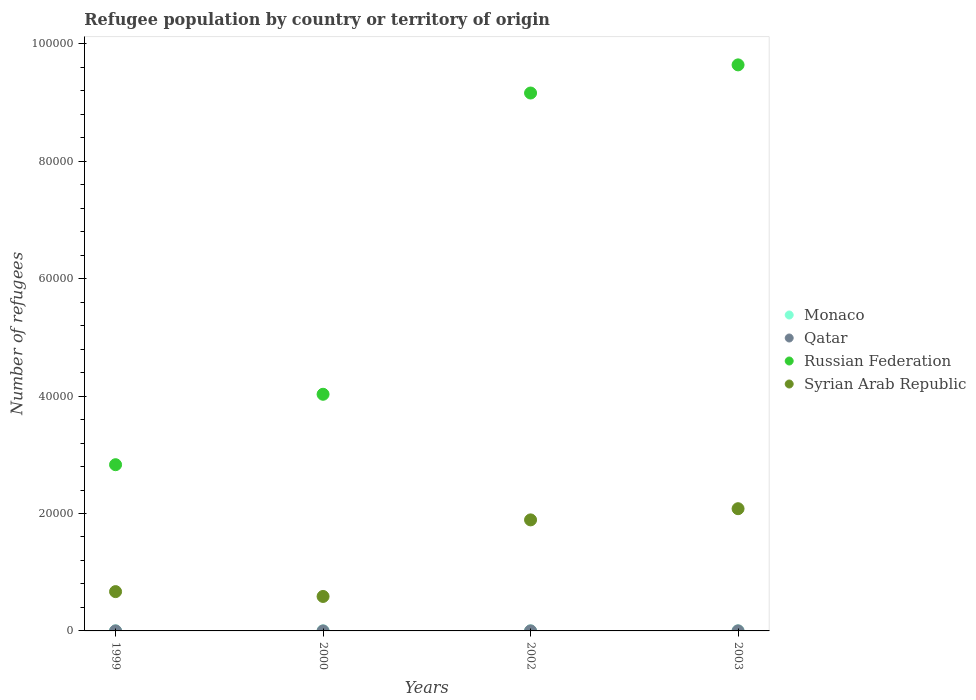What is the number of refugees in Qatar in 2003?
Your answer should be compact. 13. Across all years, what is the maximum number of refugees in Qatar?
Make the answer very short. 13. Across all years, what is the minimum number of refugees in Monaco?
Provide a succinct answer. 1. In which year was the number of refugees in Monaco maximum?
Offer a terse response. 1999. What is the total number of refugees in Russian Federation in the graph?
Offer a terse response. 2.57e+05. What is the difference between the number of refugees in Monaco in 2002 and that in 2003?
Give a very brief answer. 0. What is the difference between the number of refugees in Russian Federation in 2003 and the number of refugees in Qatar in 1999?
Offer a terse response. 9.64e+04. What is the average number of refugees in Qatar per year?
Offer a very short reply. 7.5. In how many years, is the number of refugees in Qatar greater than 44000?
Your response must be concise. 0. What is the ratio of the number of refugees in Russian Federation in 1999 to that in 2000?
Provide a short and direct response. 0.7. Is the number of refugees in Russian Federation in 1999 less than that in 2003?
Offer a very short reply. Yes. What is the difference between the highest and the second highest number of refugees in Russian Federation?
Provide a short and direct response. 4794. What is the difference between the highest and the lowest number of refugees in Monaco?
Your answer should be very brief. 0. Is it the case that in every year, the sum of the number of refugees in Syrian Arab Republic and number of refugees in Qatar  is greater than the sum of number of refugees in Russian Federation and number of refugees in Monaco?
Give a very brief answer. Yes. Is it the case that in every year, the sum of the number of refugees in Russian Federation and number of refugees in Syrian Arab Republic  is greater than the number of refugees in Qatar?
Your response must be concise. Yes. Does the number of refugees in Monaco monotonically increase over the years?
Keep it short and to the point. No. How many dotlines are there?
Ensure brevity in your answer.  4. What is the difference between two consecutive major ticks on the Y-axis?
Your answer should be compact. 2.00e+04. Are the values on the major ticks of Y-axis written in scientific E-notation?
Offer a terse response. No. Where does the legend appear in the graph?
Your answer should be compact. Center right. How many legend labels are there?
Keep it short and to the point. 4. What is the title of the graph?
Provide a succinct answer. Refugee population by country or territory of origin. What is the label or title of the Y-axis?
Give a very brief answer. Number of refugees. What is the Number of refugees of Monaco in 1999?
Offer a very short reply. 1. What is the Number of refugees in Russian Federation in 1999?
Your answer should be compact. 2.83e+04. What is the Number of refugees in Syrian Arab Republic in 1999?
Your response must be concise. 6695. What is the Number of refugees in Qatar in 2000?
Offer a very short reply. 1. What is the Number of refugees in Russian Federation in 2000?
Provide a short and direct response. 4.03e+04. What is the Number of refugees in Syrian Arab Republic in 2000?
Offer a very short reply. 5871. What is the Number of refugees of Qatar in 2002?
Your answer should be very brief. 8. What is the Number of refugees of Russian Federation in 2002?
Make the answer very short. 9.16e+04. What is the Number of refugees of Syrian Arab Republic in 2002?
Ensure brevity in your answer.  1.89e+04. What is the Number of refugees in Monaco in 2003?
Provide a succinct answer. 1. What is the Number of refugees in Russian Federation in 2003?
Your response must be concise. 9.64e+04. What is the Number of refugees of Syrian Arab Republic in 2003?
Keep it short and to the point. 2.08e+04. Across all years, what is the maximum Number of refugees of Monaco?
Provide a succinct answer. 1. Across all years, what is the maximum Number of refugees of Qatar?
Your answer should be compact. 13. Across all years, what is the maximum Number of refugees in Russian Federation?
Offer a very short reply. 9.64e+04. Across all years, what is the maximum Number of refugees in Syrian Arab Republic?
Your answer should be compact. 2.08e+04. Across all years, what is the minimum Number of refugees of Monaco?
Offer a very short reply. 1. Across all years, what is the minimum Number of refugees of Qatar?
Keep it short and to the point. 1. Across all years, what is the minimum Number of refugees in Russian Federation?
Your answer should be very brief. 2.83e+04. Across all years, what is the minimum Number of refugees in Syrian Arab Republic?
Your answer should be compact. 5871. What is the total Number of refugees in Qatar in the graph?
Make the answer very short. 30. What is the total Number of refugees of Russian Federation in the graph?
Give a very brief answer. 2.57e+05. What is the total Number of refugees of Syrian Arab Republic in the graph?
Provide a succinct answer. 5.23e+04. What is the difference between the Number of refugees of Russian Federation in 1999 and that in 2000?
Your answer should be compact. -1.20e+04. What is the difference between the Number of refugees of Syrian Arab Republic in 1999 and that in 2000?
Your answer should be very brief. 824. What is the difference between the Number of refugees in Monaco in 1999 and that in 2002?
Give a very brief answer. 0. What is the difference between the Number of refugees in Russian Federation in 1999 and that in 2002?
Give a very brief answer. -6.33e+04. What is the difference between the Number of refugees of Syrian Arab Republic in 1999 and that in 2002?
Provide a short and direct response. -1.22e+04. What is the difference between the Number of refugees in Monaco in 1999 and that in 2003?
Give a very brief answer. 0. What is the difference between the Number of refugees in Russian Federation in 1999 and that in 2003?
Ensure brevity in your answer.  -6.81e+04. What is the difference between the Number of refugees of Syrian Arab Republic in 1999 and that in 2003?
Give a very brief answer. -1.41e+04. What is the difference between the Number of refugees of Monaco in 2000 and that in 2002?
Provide a succinct answer. 0. What is the difference between the Number of refugees in Qatar in 2000 and that in 2002?
Give a very brief answer. -7. What is the difference between the Number of refugees in Russian Federation in 2000 and that in 2002?
Give a very brief answer. -5.13e+04. What is the difference between the Number of refugees in Syrian Arab Republic in 2000 and that in 2002?
Keep it short and to the point. -1.30e+04. What is the difference between the Number of refugees of Monaco in 2000 and that in 2003?
Your answer should be compact. 0. What is the difference between the Number of refugees in Qatar in 2000 and that in 2003?
Your answer should be compact. -12. What is the difference between the Number of refugees in Russian Federation in 2000 and that in 2003?
Make the answer very short. -5.61e+04. What is the difference between the Number of refugees in Syrian Arab Republic in 2000 and that in 2003?
Ensure brevity in your answer.  -1.49e+04. What is the difference between the Number of refugees of Monaco in 2002 and that in 2003?
Ensure brevity in your answer.  0. What is the difference between the Number of refugees of Russian Federation in 2002 and that in 2003?
Offer a terse response. -4794. What is the difference between the Number of refugees of Syrian Arab Republic in 2002 and that in 2003?
Offer a terse response. -1906. What is the difference between the Number of refugees of Monaco in 1999 and the Number of refugees of Qatar in 2000?
Your response must be concise. 0. What is the difference between the Number of refugees in Monaco in 1999 and the Number of refugees in Russian Federation in 2000?
Provide a succinct answer. -4.03e+04. What is the difference between the Number of refugees of Monaco in 1999 and the Number of refugees of Syrian Arab Republic in 2000?
Ensure brevity in your answer.  -5870. What is the difference between the Number of refugees in Qatar in 1999 and the Number of refugees in Russian Federation in 2000?
Your answer should be compact. -4.03e+04. What is the difference between the Number of refugees of Qatar in 1999 and the Number of refugees of Syrian Arab Republic in 2000?
Your answer should be compact. -5863. What is the difference between the Number of refugees of Russian Federation in 1999 and the Number of refugees of Syrian Arab Republic in 2000?
Give a very brief answer. 2.24e+04. What is the difference between the Number of refugees in Monaco in 1999 and the Number of refugees in Russian Federation in 2002?
Your answer should be compact. -9.16e+04. What is the difference between the Number of refugees in Monaco in 1999 and the Number of refugees in Syrian Arab Republic in 2002?
Keep it short and to the point. -1.89e+04. What is the difference between the Number of refugees of Qatar in 1999 and the Number of refugees of Russian Federation in 2002?
Give a very brief answer. -9.16e+04. What is the difference between the Number of refugees in Qatar in 1999 and the Number of refugees in Syrian Arab Republic in 2002?
Make the answer very short. -1.89e+04. What is the difference between the Number of refugees in Russian Federation in 1999 and the Number of refugees in Syrian Arab Republic in 2002?
Ensure brevity in your answer.  9401. What is the difference between the Number of refugees of Monaco in 1999 and the Number of refugees of Qatar in 2003?
Keep it short and to the point. -12. What is the difference between the Number of refugees of Monaco in 1999 and the Number of refugees of Russian Federation in 2003?
Keep it short and to the point. -9.64e+04. What is the difference between the Number of refugees in Monaco in 1999 and the Number of refugees in Syrian Arab Republic in 2003?
Ensure brevity in your answer.  -2.08e+04. What is the difference between the Number of refugees in Qatar in 1999 and the Number of refugees in Russian Federation in 2003?
Provide a succinct answer. -9.64e+04. What is the difference between the Number of refugees of Qatar in 1999 and the Number of refugees of Syrian Arab Republic in 2003?
Provide a succinct answer. -2.08e+04. What is the difference between the Number of refugees of Russian Federation in 1999 and the Number of refugees of Syrian Arab Republic in 2003?
Provide a short and direct response. 7495. What is the difference between the Number of refugees of Monaco in 2000 and the Number of refugees of Qatar in 2002?
Make the answer very short. -7. What is the difference between the Number of refugees of Monaco in 2000 and the Number of refugees of Russian Federation in 2002?
Your answer should be very brief. -9.16e+04. What is the difference between the Number of refugees in Monaco in 2000 and the Number of refugees in Syrian Arab Republic in 2002?
Keep it short and to the point. -1.89e+04. What is the difference between the Number of refugees in Qatar in 2000 and the Number of refugees in Russian Federation in 2002?
Give a very brief answer. -9.16e+04. What is the difference between the Number of refugees of Qatar in 2000 and the Number of refugees of Syrian Arab Republic in 2002?
Provide a succinct answer. -1.89e+04. What is the difference between the Number of refugees in Russian Federation in 2000 and the Number of refugees in Syrian Arab Republic in 2002?
Give a very brief answer. 2.14e+04. What is the difference between the Number of refugees in Monaco in 2000 and the Number of refugees in Russian Federation in 2003?
Offer a terse response. -9.64e+04. What is the difference between the Number of refugees of Monaco in 2000 and the Number of refugees of Syrian Arab Republic in 2003?
Provide a succinct answer. -2.08e+04. What is the difference between the Number of refugees of Qatar in 2000 and the Number of refugees of Russian Federation in 2003?
Your response must be concise. -9.64e+04. What is the difference between the Number of refugees in Qatar in 2000 and the Number of refugees in Syrian Arab Republic in 2003?
Your answer should be compact. -2.08e+04. What is the difference between the Number of refugees of Russian Federation in 2000 and the Number of refugees of Syrian Arab Republic in 2003?
Give a very brief answer. 1.95e+04. What is the difference between the Number of refugees of Monaco in 2002 and the Number of refugees of Qatar in 2003?
Your answer should be compact. -12. What is the difference between the Number of refugees in Monaco in 2002 and the Number of refugees in Russian Federation in 2003?
Offer a terse response. -9.64e+04. What is the difference between the Number of refugees in Monaco in 2002 and the Number of refugees in Syrian Arab Republic in 2003?
Offer a terse response. -2.08e+04. What is the difference between the Number of refugees in Qatar in 2002 and the Number of refugees in Russian Federation in 2003?
Offer a very short reply. -9.64e+04. What is the difference between the Number of refugees of Qatar in 2002 and the Number of refugees of Syrian Arab Republic in 2003?
Offer a terse response. -2.08e+04. What is the difference between the Number of refugees of Russian Federation in 2002 and the Number of refugees of Syrian Arab Republic in 2003?
Offer a very short reply. 7.08e+04. What is the average Number of refugees of Monaco per year?
Provide a short and direct response. 1. What is the average Number of refugees in Qatar per year?
Offer a terse response. 7.5. What is the average Number of refugees in Russian Federation per year?
Your answer should be compact. 6.42e+04. What is the average Number of refugees in Syrian Arab Republic per year?
Provide a short and direct response. 1.31e+04. In the year 1999, what is the difference between the Number of refugees in Monaco and Number of refugees in Qatar?
Ensure brevity in your answer.  -7. In the year 1999, what is the difference between the Number of refugees in Monaco and Number of refugees in Russian Federation?
Provide a succinct answer. -2.83e+04. In the year 1999, what is the difference between the Number of refugees of Monaco and Number of refugees of Syrian Arab Republic?
Provide a short and direct response. -6694. In the year 1999, what is the difference between the Number of refugees of Qatar and Number of refugees of Russian Federation?
Keep it short and to the point. -2.83e+04. In the year 1999, what is the difference between the Number of refugees of Qatar and Number of refugees of Syrian Arab Republic?
Your response must be concise. -6687. In the year 1999, what is the difference between the Number of refugees of Russian Federation and Number of refugees of Syrian Arab Republic?
Provide a succinct answer. 2.16e+04. In the year 2000, what is the difference between the Number of refugees in Monaco and Number of refugees in Qatar?
Offer a terse response. 0. In the year 2000, what is the difference between the Number of refugees of Monaco and Number of refugees of Russian Federation?
Offer a very short reply. -4.03e+04. In the year 2000, what is the difference between the Number of refugees of Monaco and Number of refugees of Syrian Arab Republic?
Offer a very short reply. -5870. In the year 2000, what is the difference between the Number of refugees of Qatar and Number of refugees of Russian Federation?
Provide a short and direct response. -4.03e+04. In the year 2000, what is the difference between the Number of refugees in Qatar and Number of refugees in Syrian Arab Republic?
Your answer should be compact. -5870. In the year 2000, what is the difference between the Number of refugees of Russian Federation and Number of refugees of Syrian Arab Republic?
Ensure brevity in your answer.  3.44e+04. In the year 2002, what is the difference between the Number of refugees in Monaco and Number of refugees in Qatar?
Your answer should be very brief. -7. In the year 2002, what is the difference between the Number of refugees of Monaco and Number of refugees of Russian Federation?
Keep it short and to the point. -9.16e+04. In the year 2002, what is the difference between the Number of refugees in Monaco and Number of refugees in Syrian Arab Republic?
Your response must be concise. -1.89e+04. In the year 2002, what is the difference between the Number of refugees of Qatar and Number of refugees of Russian Federation?
Your answer should be compact. -9.16e+04. In the year 2002, what is the difference between the Number of refugees in Qatar and Number of refugees in Syrian Arab Republic?
Ensure brevity in your answer.  -1.89e+04. In the year 2002, what is the difference between the Number of refugees of Russian Federation and Number of refugees of Syrian Arab Republic?
Keep it short and to the point. 7.27e+04. In the year 2003, what is the difference between the Number of refugees in Monaco and Number of refugees in Russian Federation?
Provide a succinct answer. -9.64e+04. In the year 2003, what is the difference between the Number of refugees of Monaco and Number of refugees of Syrian Arab Republic?
Make the answer very short. -2.08e+04. In the year 2003, what is the difference between the Number of refugees in Qatar and Number of refugees in Russian Federation?
Offer a very short reply. -9.64e+04. In the year 2003, what is the difference between the Number of refugees in Qatar and Number of refugees in Syrian Arab Republic?
Offer a terse response. -2.08e+04. In the year 2003, what is the difference between the Number of refugees in Russian Federation and Number of refugees in Syrian Arab Republic?
Provide a short and direct response. 7.56e+04. What is the ratio of the Number of refugees of Russian Federation in 1999 to that in 2000?
Provide a short and direct response. 0.7. What is the ratio of the Number of refugees in Syrian Arab Republic in 1999 to that in 2000?
Make the answer very short. 1.14. What is the ratio of the Number of refugees of Monaco in 1999 to that in 2002?
Provide a short and direct response. 1. What is the ratio of the Number of refugees of Russian Federation in 1999 to that in 2002?
Your answer should be compact. 0.31. What is the ratio of the Number of refugees of Syrian Arab Republic in 1999 to that in 2002?
Offer a terse response. 0.35. What is the ratio of the Number of refugees of Qatar in 1999 to that in 2003?
Offer a very short reply. 0.62. What is the ratio of the Number of refugees in Russian Federation in 1999 to that in 2003?
Provide a short and direct response. 0.29. What is the ratio of the Number of refugees in Syrian Arab Republic in 1999 to that in 2003?
Your answer should be compact. 0.32. What is the ratio of the Number of refugees of Monaco in 2000 to that in 2002?
Offer a terse response. 1. What is the ratio of the Number of refugees in Russian Federation in 2000 to that in 2002?
Your response must be concise. 0.44. What is the ratio of the Number of refugees of Syrian Arab Republic in 2000 to that in 2002?
Keep it short and to the point. 0.31. What is the ratio of the Number of refugees of Qatar in 2000 to that in 2003?
Offer a terse response. 0.08. What is the ratio of the Number of refugees of Russian Federation in 2000 to that in 2003?
Provide a succinct answer. 0.42. What is the ratio of the Number of refugees in Syrian Arab Republic in 2000 to that in 2003?
Offer a terse response. 0.28. What is the ratio of the Number of refugees in Monaco in 2002 to that in 2003?
Offer a terse response. 1. What is the ratio of the Number of refugees of Qatar in 2002 to that in 2003?
Ensure brevity in your answer.  0.62. What is the ratio of the Number of refugees of Russian Federation in 2002 to that in 2003?
Your response must be concise. 0.95. What is the ratio of the Number of refugees in Syrian Arab Republic in 2002 to that in 2003?
Provide a short and direct response. 0.91. What is the difference between the highest and the second highest Number of refugees of Monaco?
Ensure brevity in your answer.  0. What is the difference between the highest and the second highest Number of refugees in Russian Federation?
Provide a succinct answer. 4794. What is the difference between the highest and the second highest Number of refugees in Syrian Arab Republic?
Your answer should be very brief. 1906. What is the difference between the highest and the lowest Number of refugees of Russian Federation?
Keep it short and to the point. 6.81e+04. What is the difference between the highest and the lowest Number of refugees of Syrian Arab Republic?
Offer a terse response. 1.49e+04. 